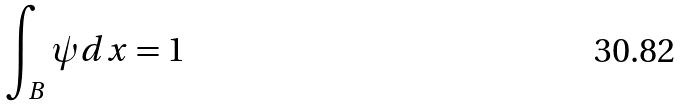<formula> <loc_0><loc_0><loc_500><loc_500>\int _ { B } \psi d x = 1</formula> 